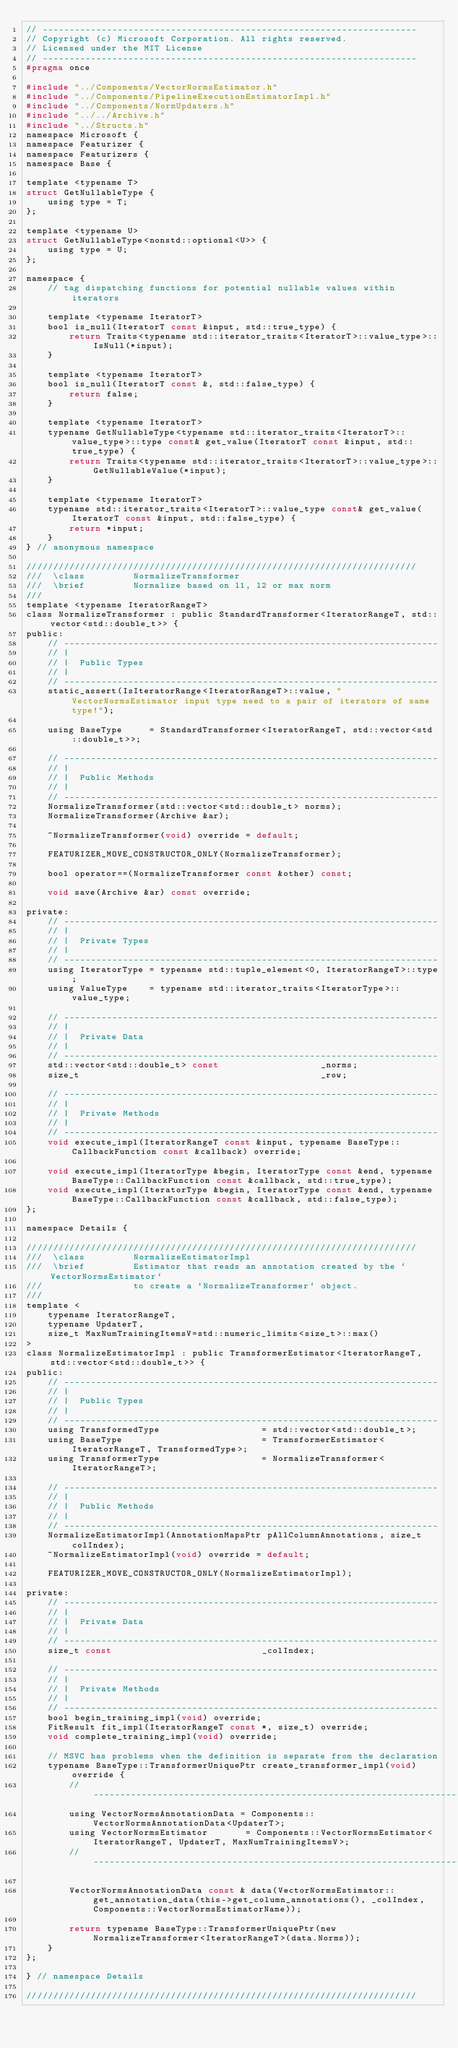<code> <loc_0><loc_0><loc_500><loc_500><_C_>// ----------------------------------------------------------------------
// Copyright (c) Microsoft Corporation. All rights reserved.
// Licensed under the MIT License
// ----------------------------------------------------------------------
#pragma once

#include "../Components/VectorNormsEstimator.h"
#include "../Components/PipelineExecutionEstimatorImpl.h"
#include "../Components/NormUpdaters.h"
#include "../../Archive.h"
#include "../Structs.h"
namespace Microsoft {
namespace Featurizer {
namespace Featurizers {
namespace Base {

template <typename T>
struct GetNullableType {
    using type = T;
};

template <typename U>
struct GetNullableType<nonstd::optional<U>> {
    using type = U;
};

namespace {
    // tag dispatching functions for potential nullable values within iterators

    template <typename IteratorT>
    bool is_null(IteratorT const &input, std::true_type) {
        return Traits<typename std::iterator_traits<IteratorT>::value_type>::IsNull(*input);
    }

    template <typename IteratorT>
    bool is_null(IteratorT const &, std::false_type) {
        return false;
    }

    template <typename IteratorT>
    typename GetNullableType<typename std::iterator_traits<IteratorT>::value_type>::type const& get_value(IteratorT const &input, std::true_type) {
        return Traits<typename std::iterator_traits<IteratorT>::value_type>::GetNullableValue(*input);
    }

    template <typename IteratorT>
    typename std::iterator_traits<IteratorT>::value_type const& get_value(IteratorT const &input, std::false_type) {
        return *input;
    }
} // anonymous namespace

/////////////////////////////////////////////////////////////////////////
///  \class         NormalizeTransformer
///  \brief         Normalize based on l1, l2 or max norm
///
template <typename IteratorRangeT>
class NormalizeTransformer : public StandardTransformer<IteratorRangeT, std::vector<std::double_t>> {
public:
    // ----------------------------------------------------------------------
    // |
    // |  Public Types
    // |
    // ----------------------------------------------------------------------
    static_assert(IsIteratorRange<IteratorRangeT>::value, "VectorNormsEstimator input type need to a pair of iterators of same type!");

    using BaseType     = StandardTransformer<IteratorRangeT, std::vector<std::double_t>>;

    // ----------------------------------------------------------------------
    // |
    // |  Public Methods
    // |
    // ----------------------------------------------------------------------
    NormalizeTransformer(std::vector<std::double_t> norms);
    NormalizeTransformer(Archive &ar);

    ~NormalizeTransformer(void) override = default;

    FEATURIZER_MOVE_CONSTRUCTOR_ONLY(NormalizeTransformer);

    bool operator==(NormalizeTransformer const &other) const;

    void save(Archive &ar) const override;

private:
    // ----------------------------------------------------------------------
    // |
    // |  Private Types
    // |
    // ----------------------------------------------------------------------
    using IteratorType = typename std::tuple_element<0, IteratorRangeT>::type;
    using ValueType    = typename std::iterator_traits<IteratorType>::value_type;

    // ----------------------------------------------------------------------
    // |
    // |  Private Data
    // |
    // ----------------------------------------------------------------------
    std::vector<std::double_t> const                   _norms;
    size_t                                             _row;

    // ----------------------------------------------------------------------
    // |
    // |  Private Methods
    // |
    // ----------------------------------------------------------------------
    void execute_impl(IteratorRangeT const &input, typename BaseType::CallbackFunction const &callback) override;

    void execute_impl(IteratorType &begin, IteratorType const &end, typename BaseType::CallbackFunction const &callback, std::true_type);
    void execute_impl(IteratorType &begin, IteratorType const &end, typename BaseType::CallbackFunction const &callback, std::false_type);
};

namespace Details {

/////////////////////////////////////////////////////////////////////////
///  \class         NormalizeEstimatorImpl
///  \brief         Estimator that reads an annotation created by the `VectorNormsEstimator`
///                 to create a `NormalizeTransformer` object.
///
template <
    typename IteratorRangeT,
    typename UpdaterT,
    size_t MaxNumTrainingItemsV=std::numeric_limits<size_t>::max()
>
class NormalizeEstimatorImpl : public TransformerEstimator<IteratorRangeT, std::vector<std::double_t>> {
public:
    // ----------------------------------------------------------------------
    // |
    // |  Public Types
    // |
    // ----------------------------------------------------------------------
    using TransformedType                   = std::vector<std::double_t>;
    using BaseType                          = TransformerEstimator<IteratorRangeT, TransformedType>;
    using TransformerType                   = NormalizeTransformer<IteratorRangeT>;

    // ----------------------------------------------------------------------
    // |
    // |  Public Methods
    // |
    // ----------------------------------------------------------------------
    NormalizeEstimatorImpl(AnnotationMapsPtr pAllColumnAnnotations, size_t colIndex);
    ~NormalizeEstimatorImpl(void) override = default;

    FEATURIZER_MOVE_CONSTRUCTOR_ONLY(NormalizeEstimatorImpl);

private:
    // ----------------------------------------------------------------------
    // |
    // |  Private Data
    // |
    // ----------------------------------------------------------------------
    size_t const                            _colIndex;

    // ----------------------------------------------------------------------
    // |
    // |  Private Methods
    // |
    // ----------------------------------------------------------------------
    bool begin_training_impl(void) override;
    FitResult fit_impl(IteratorRangeT const *, size_t) override;
    void complete_training_impl(void) override;

    // MSVC has problems when the definition is separate from the declaration
    typename BaseType::TransformerUniquePtr create_transformer_impl(void) override {
        // ----------------------------------------------------------------------
        using VectorNormsAnnotationData = Components::VectorNormsAnnotationData<UpdaterT>;
        using VectorNormsEstimator       = Components::VectorNormsEstimator<IteratorRangeT, UpdaterT, MaxNumTrainingItemsV>;
        // ----------------------------------------------------------------------

        VectorNormsAnnotationData const & data(VectorNormsEstimator::get_annotation_data(this->get_column_annotations(), _colIndex, Components::VectorNormsEstimatorName));

        return typename BaseType::TransformerUniquePtr(new NormalizeTransformer<IteratorRangeT>(data.Norms));
    }
};

} // namespace Details

/////////////////////////////////////////////////////////////////////////</code> 